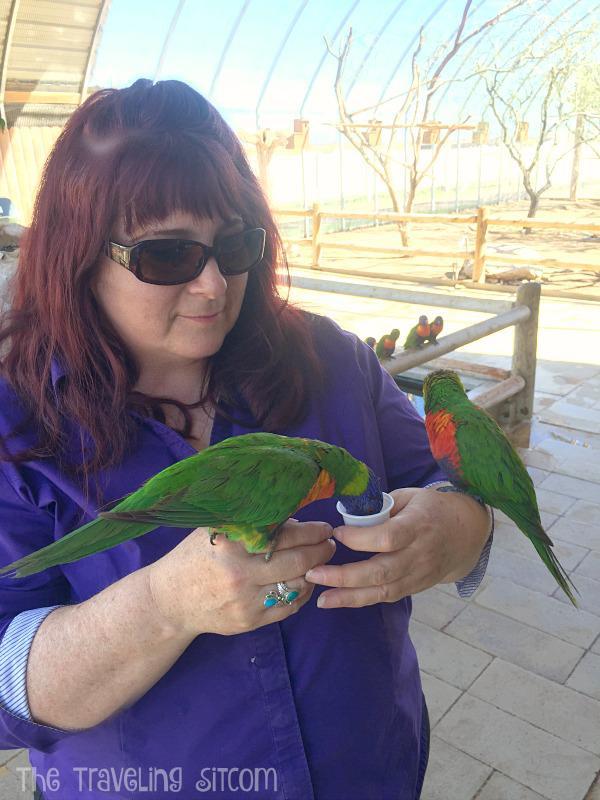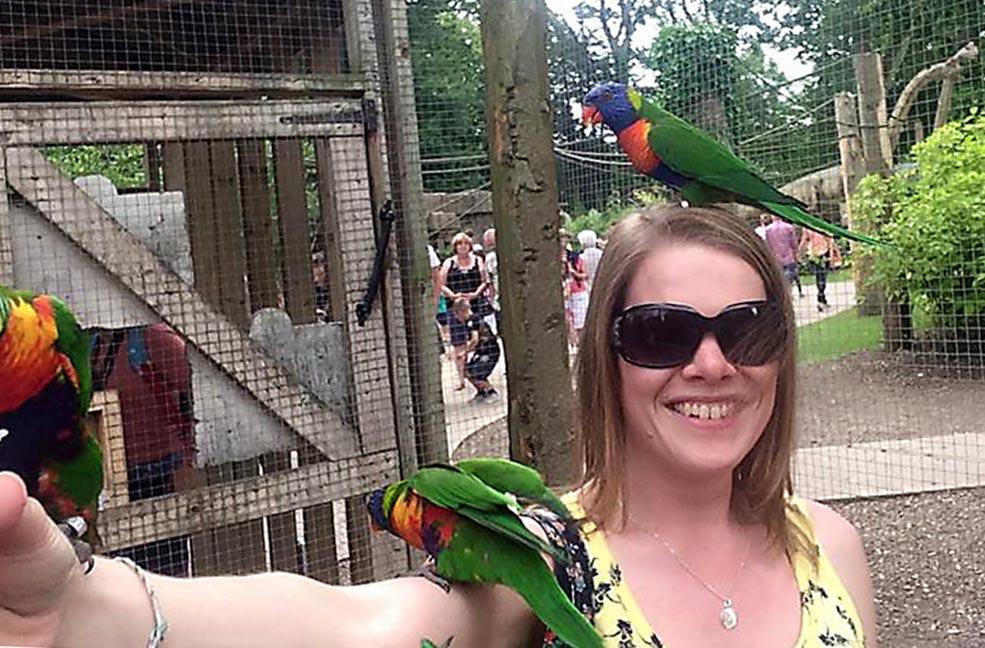The first image is the image on the left, the second image is the image on the right. For the images displayed, is the sentence "One smiling woman who is not wearing a hat has exactly one green bird perched on her head." factually correct? Answer yes or no. Yes. The first image is the image on the left, the second image is the image on the right. Assess this claim about the two images: "An image shows a person with more than one parrot atop her head.". Correct or not? Answer yes or no. No. 